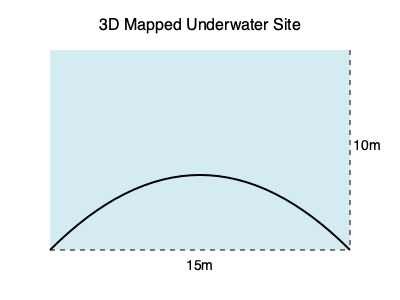Based on the 3D mapping of an underwater archaeological site shown above, estimate its volume. The site measures 15m in length, 10m in height, and has an average width of 8m. Assume the site's cross-section can be approximated as a semi-ellipse. To estimate the volume of the underwater archaeological site, we'll follow these steps:

1. Identify the shape: The site's cross-section is approximated as a semi-ellipse.

2. Recall the formula for the area of a semi-ellipse:
   $A = \frac{1}{2} \cdot \pi \cdot a \cdot b$
   Where $a$ is half the width and $b$ is the height.

3. Calculate the cross-sectional area:
   $a = 8m / 2 = 4m$
   $b = 10m$
   $A = \frac{1}{2} \cdot \pi \cdot 4m \cdot 10m = 20\pi$ m²

4. To find the volume, multiply the cross-sectional area by the length:
   $V = A \cdot l$
   Where $l$ is the length of the site.

5. Calculate the volume:
   $V = 20\pi$ m² $\cdot 15m = 300\pi$ m³

6. Evaluate the result:
   $300\pi \approx 942.48$ m³

Therefore, the estimated volume of the underwater archaeological site is approximately 942.48 cubic meters.
Answer: $942.48$ m³ 